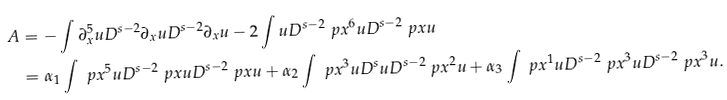<formula> <loc_0><loc_0><loc_500><loc_500>A & = - \int \partial _ { x } ^ { 5 } u D ^ { s - 2 } \partial _ { x } u D ^ { s - 2 } \partial _ { x } u - 2 \int u D ^ { s - 2 } \ p x ^ { 6 } u D ^ { s - 2 } \ p x u \\ & = \alpha _ { 1 } \int \ p x ^ { 5 } u D ^ { s - 2 } \ p x u D ^ { s - 2 } \ p x u + \alpha _ { 2 } \int \ p x ^ { 3 } u D ^ { s } u D ^ { s - 2 } \ p x ^ { 2 } u + \alpha _ { 3 } \int \ p x ^ { 1 } u D ^ { s - 2 } \ p x ^ { 3 } u D ^ { s - 2 } \ p x ^ { 3 } u .</formula> 